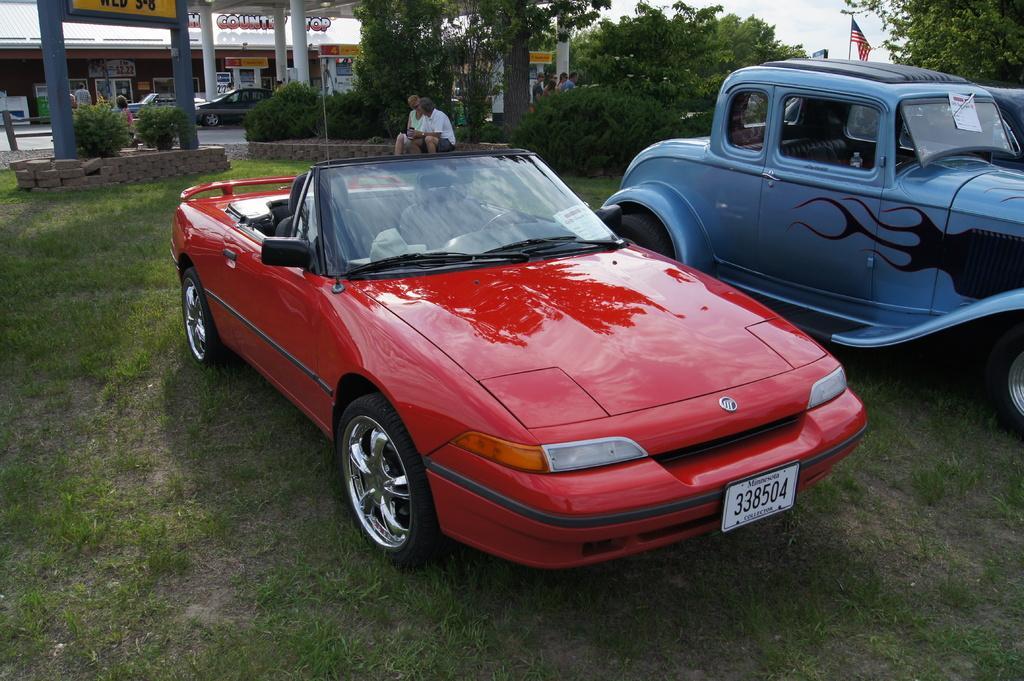How would you summarize this image in a sentence or two? In the image in the center we can see two different color cars. In the background we can see the sky,clouds,trees,plants,grass,pillars,banners,vehicles,building,wall,roof,flag and few people were sitting. 